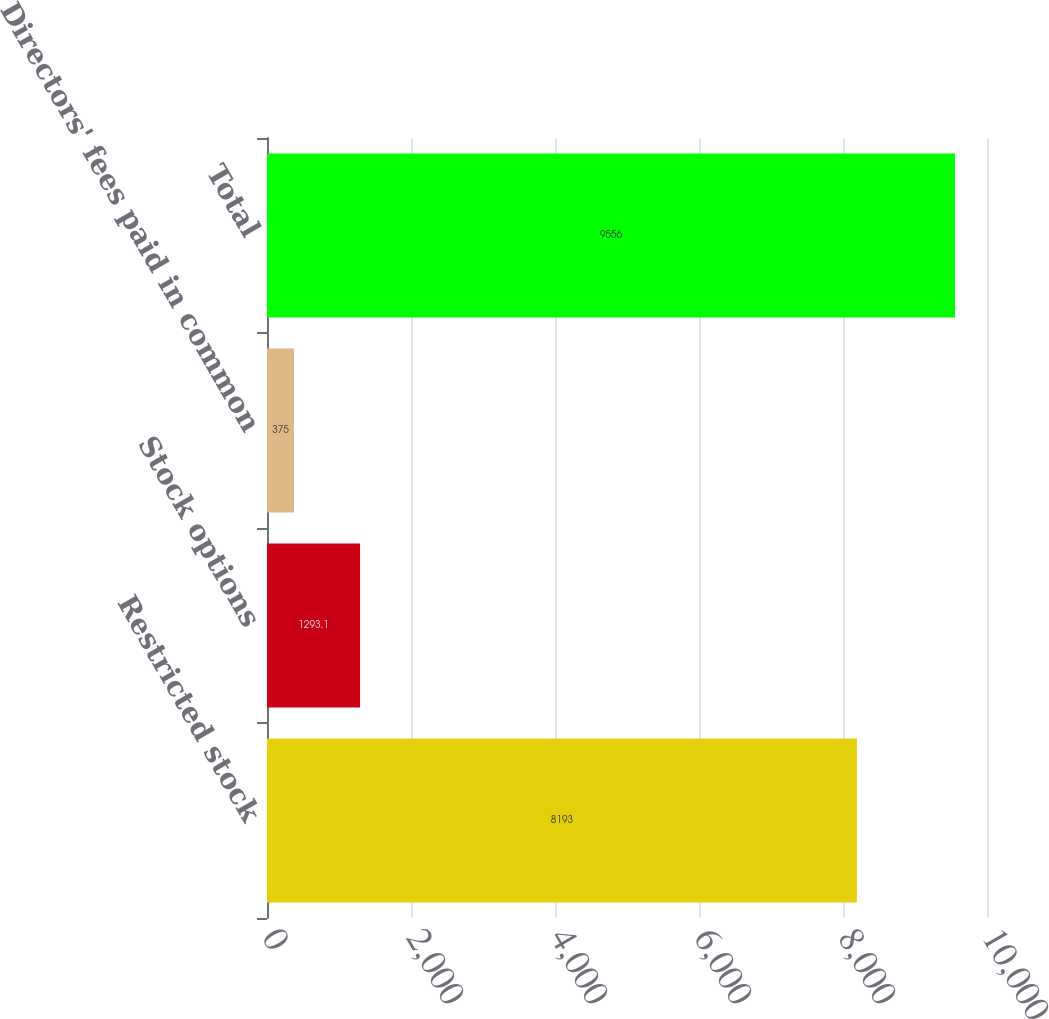Convert chart to OTSL. <chart><loc_0><loc_0><loc_500><loc_500><bar_chart><fcel>Restricted stock<fcel>Stock options<fcel>Directors' fees paid in common<fcel>Total<nl><fcel>8193<fcel>1293.1<fcel>375<fcel>9556<nl></chart> 